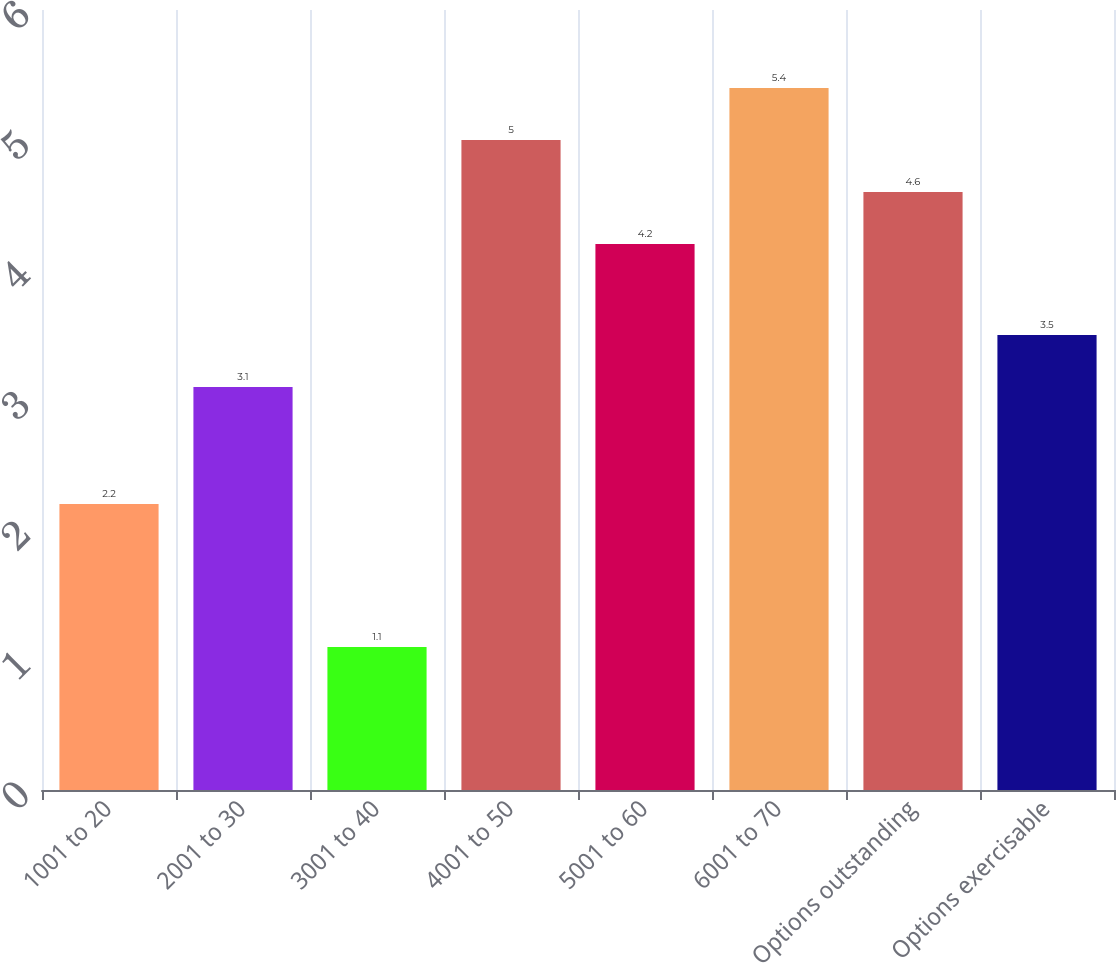Convert chart. <chart><loc_0><loc_0><loc_500><loc_500><bar_chart><fcel>1001 to 20<fcel>2001 to 30<fcel>3001 to 40<fcel>4001 to 50<fcel>5001 to 60<fcel>6001 to 70<fcel>Options outstanding<fcel>Options exercisable<nl><fcel>2.2<fcel>3.1<fcel>1.1<fcel>5<fcel>4.2<fcel>5.4<fcel>4.6<fcel>3.5<nl></chart> 